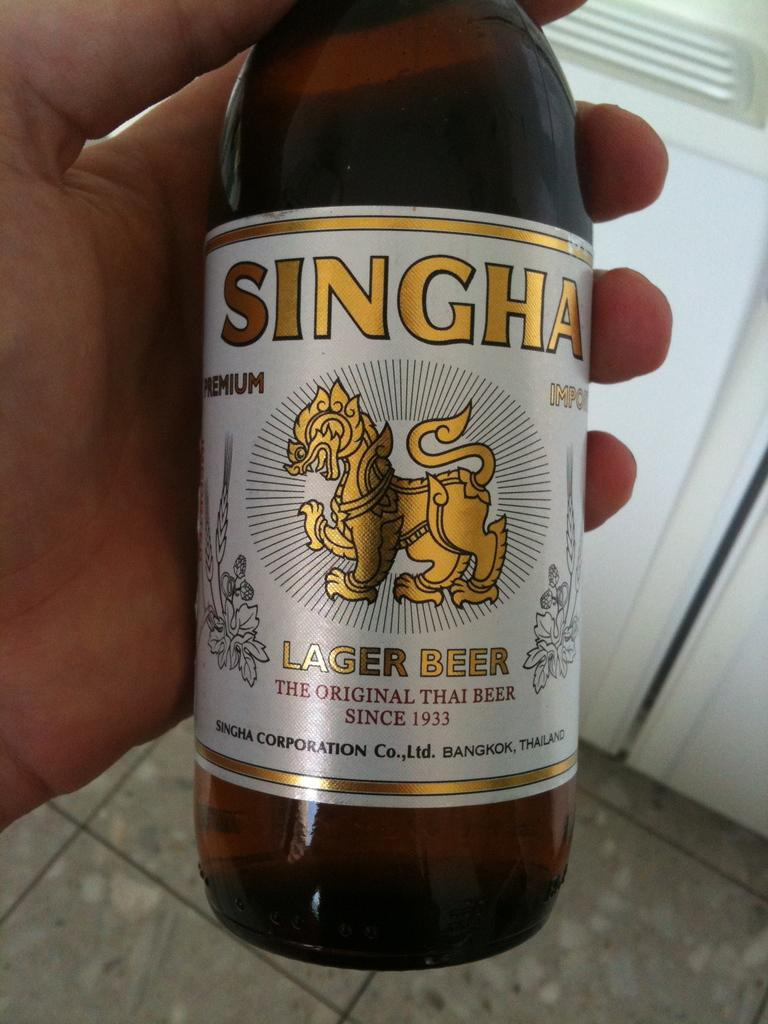Who or what is present in the image? There is a person in the image. What is the person holding in the image? The person is holding a beer bottle. What can be seen in the background of the image? There is a wall in the background of the image. What type of honey is being produced by the arm in the image? There is no arm or honey present in the image. How does the ray interact with the person in the image? There is no ray present in the image; it only features a person holding a beer bottle and a wall in the background. 